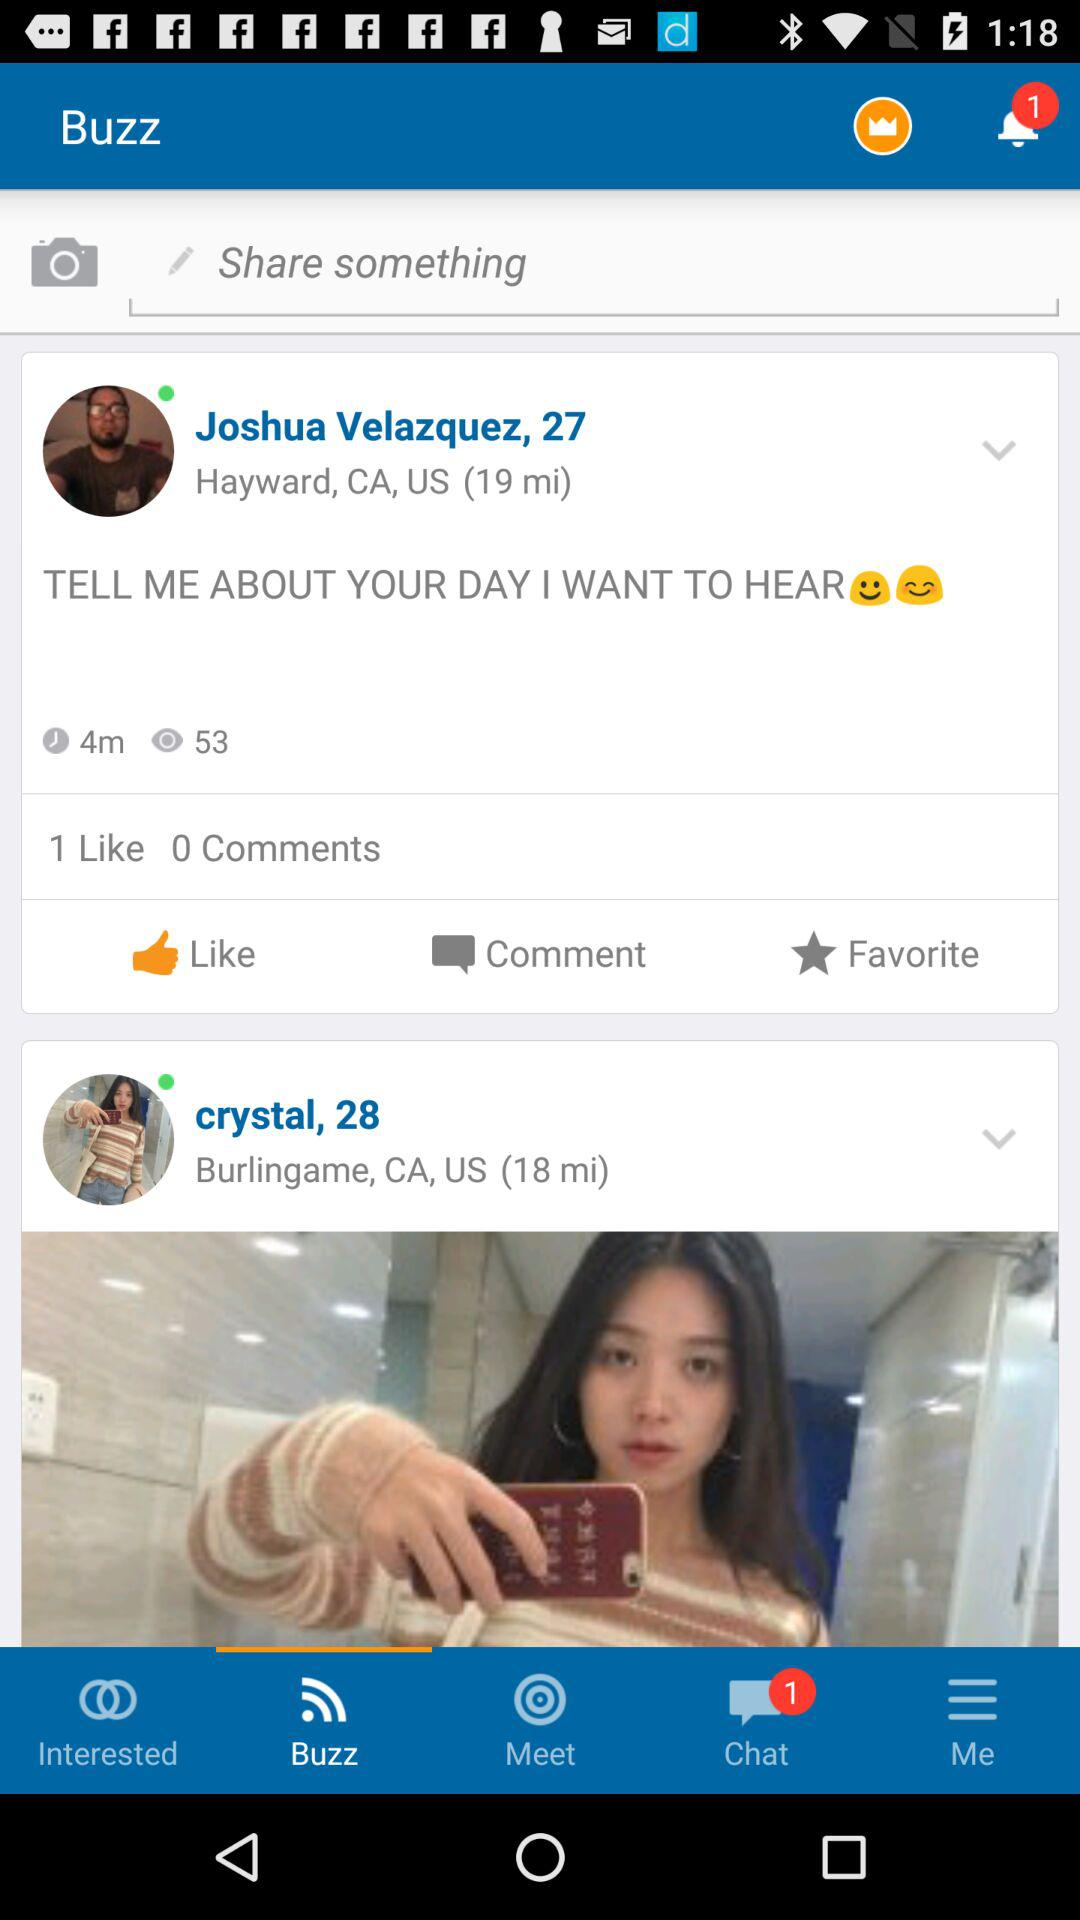How many unread notifications are there? There is 1 unread notification. 